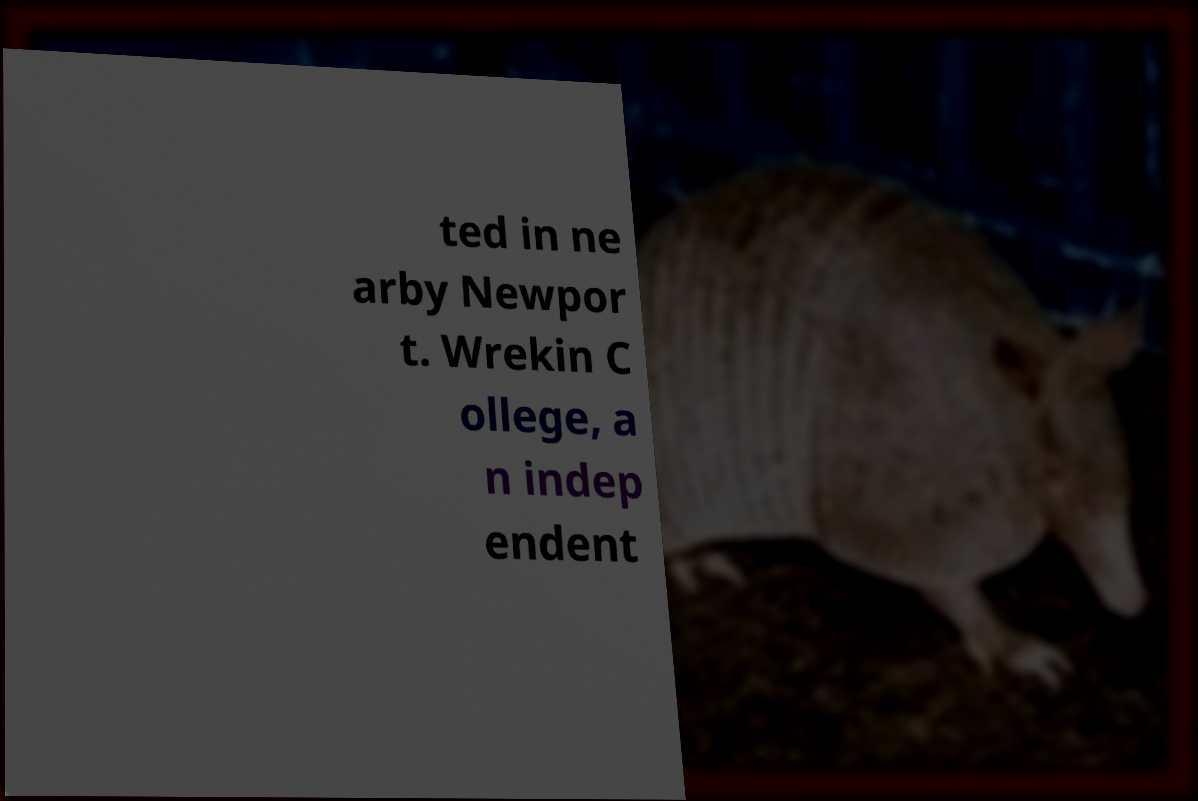There's text embedded in this image that I need extracted. Can you transcribe it verbatim? ted in ne arby Newpor t. Wrekin C ollege, a n indep endent 